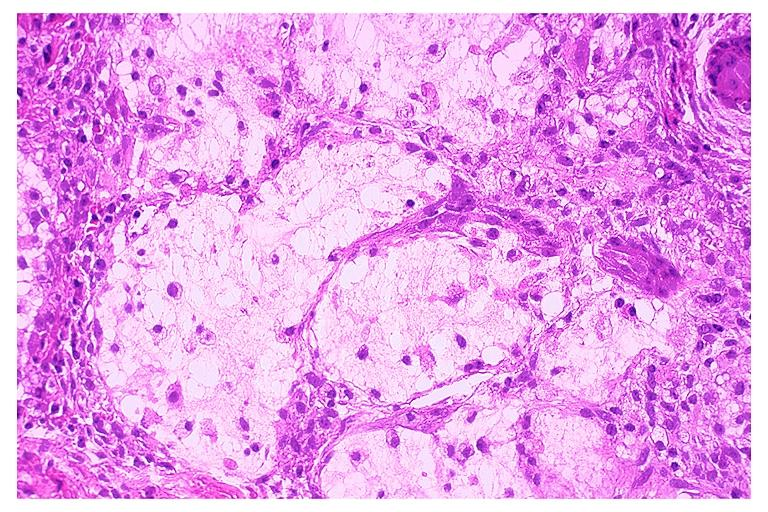what does this image show?
Answer the question using a single word or phrase. Necrotizing sialometaplasia 